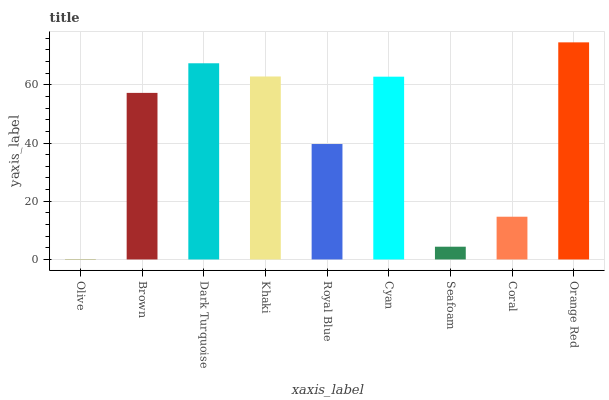Is Olive the minimum?
Answer yes or no. Yes. Is Orange Red the maximum?
Answer yes or no. Yes. Is Brown the minimum?
Answer yes or no. No. Is Brown the maximum?
Answer yes or no. No. Is Brown greater than Olive?
Answer yes or no. Yes. Is Olive less than Brown?
Answer yes or no. Yes. Is Olive greater than Brown?
Answer yes or no. No. Is Brown less than Olive?
Answer yes or no. No. Is Brown the high median?
Answer yes or no. Yes. Is Brown the low median?
Answer yes or no. Yes. Is Khaki the high median?
Answer yes or no. No. Is Orange Red the low median?
Answer yes or no. No. 